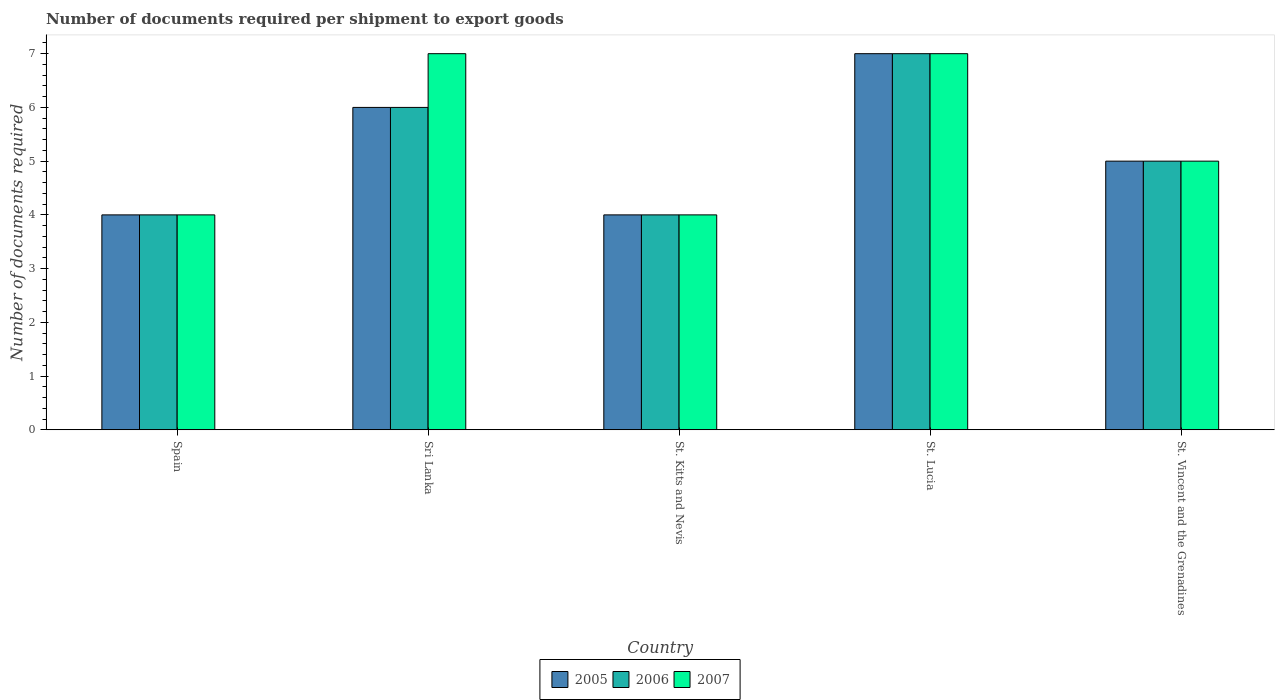How many different coloured bars are there?
Give a very brief answer. 3. How many groups of bars are there?
Your answer should be compact. 5. Are the number of bars on each tick of the X-axis equal?
Make the answer very short. Yes. How many bars are there on the 3rd tick from the right?
Provide a short and direct response. 3. Across all countries, what is the minimum number of documents required per shipment to export goods in 2005?
Ensure brevity in your answer.  4. In which country was the number of documents required per shipment to export goods in 2007 maximum?
Offer a very short reply. Sri Lanka. In which country was the number of documents required per shipment to export goods in 2006 minimum?
Your answer should be compact. Spain. In how many countries, is the number of documents required per shipment to export goods in 2006 greater than 5?
Offer a terse response. 2. What is the difference between the highest and the second highest number of documents required per shipment to export goods in 2007?
Provide a succinct answer. -2. What is the difference between the highest and the lowest number of documents required per shipment to export goods in 2005?
Provide a succinct answer. 3. In how many countries, is the number of documents required per shipment to export goods in 2006 greater than the average number of documents required per shipment to export goods in 2006 taken over all countries?
Provide a short and direct response. 2. Is the sum of the number of documents required per shipment to export goods in 2007 in Spain and St. Kitts and Nevis greater than the maximum number of documents required per shipment to export goods in 2005 across all countries?
Your answer should be very brief. Yes. What does the 3rd bar from the left in St. Lucia represents?
Keep it short and to the point. 2007. How many countries are there in the graph?
Ensure brevity in your answer.  5. Does the graph contain any zero values?
Your answer should be very brief. No. Where does the legend appear in the graph?
Make the answer very short. Bottom center. How many legend labels are there?
Your answer should be very brief. 3. What is the title of the graph?
Your answer should be compact. Number of documents required per shipment to export goods. What is the label or title of the Y-axis?
Your response must be concise. Number of documents required. What is the Number of documents required in 2005 in Spain?
Your answer should be very brief. 4. What is the Number of documents required of 2007 in Spain?
Your response must be concise. 4. What is the Number of documents required of 2005 in Sri Lanka?
Give a very brief answer. 6. What is the Number of documents required of 2006 in Sri Lanka?
Ensure brevity in your answer.  6. What is the Number of documents required of 2005 in St. Kitts and Nevis?
Give a very brief answer. 4. What is the Number of documents required in 2006 in St. Kitts and Nevis?
Provide a short and direct response. 4. What is the Number of documents required in 2006 in St. Vincent and the Grenadines?
Provide a short and direct response. 5. What is the Number of documents required of 2007 in St. Vincent and the Grenadines?
Provide a short and direct response. 5. Across all countries, what is the maximum Number of documents required of 2005?
Ensure brevity in your answer.  7. Across all countries, what is the maximum Number of documents required of 2007?
Your answer should be compact. 7. Across all countries, what is the minimum Number of documents required in 2005?
Make the answer very short. 4. Across all countries, what is the minimum Number of documents required of 2007?
Your answer should be compact. 4. What is the total Number of documents required in 2005 in the graph?
Provide a short and direct response. 26. What is the total Number of documents required in 2007 in the graph?
Make the answer very short. 27. What is the difference between the Number of documents required of 2005 in Spain and that in Sri Lanka?
Make the answer very short. -2. What is the difference between the Number of documents required of 2007 in Spain and that in Sri Lanka?
Provide a short and direct response. -3. What is the difference between the Number of documents required of 2006 in Spain and that in St. Kitts and Nevis?
Give a very brief answer. 0. What is the difference between the Number of documents required of 2007 in Spain and that in St. Kitts and Nevis?
Make the answer very short. 0. What is the difference between the Number of documents required of 2007 in Spain and that in St. Lucia?
Your answer should be compact. -3. What is the difference between the Number of documents required of 2006 in Spain and that in St. Vincent and the Grenadines?
Offer a terse response. -1. What is the difference between the Number of documents required in 2006 in Sri Lanka and that in St. Lucia?
Keep it short and to the point. -1. What is the difference between the Number of documents required of 2007 in Sri Lanka and that in St. Lucia?
Offer a very short reply. 0. What is the difference between the Number of documents required in 2005 in Sri Lanka and that in St. Vincent and the Grenadines?
Your response must be concise. 1. What is the difference between the Number of documents required in 2006 in Sri Lanka and that in St. Vincent and the Grenadines?
Provide a succinct answer. 1. What is the difference between the Number of documents required in 2007 in Sri Lanka and that in St. Vincent and the Grenadines?
Offer a terse response. 2. What is the difference between the Number of documents required of 2005 in St. Kitts and Nevis and that in St. Lucia?
Your answer should be compact. -3. What is the difference between the Number of documents required in 2006 in St. Kitts and Nevis and that in St. Vincent and the Grenadines?
Keep it short and to the point. -1. What is the difference between the Number of documents required of 2007 in St. Kitts and Nevis and that in St. Vincent and the Grenadines?
Your answer should be compact. -1. What is the difference between the Number of documents required in 2005 in St. Lucia and that in St. Vincent and the Grenadines?
Provide a short and direct response. 2. What is the difference between the Number of documents required in 2007 in St. Lucia and that in St. Vincent and the Grenadines?
Keep it short and to the point. 2. What is the difference between the Number of documents required in 2005 in Spain and the Number of documents required in 2007 in Sri Lanka?
Ensure brevity in your answer.  -3. What is the difference between the Number of documents required in 2006 in Spain and the Number of documents required in 2007 in Sri Lanka?
Ensure brevity in your answer.  -3. What is the difference between the Number of documents required of 2005 in Spain and the Number of documents required of 2006 in St. Kitts and Nevis?
Offer a terse response. 0. What is the difference between the Number of documents required in 2006 in Spain and the Number of documents required in 2007 in St. Kitts and Nevis?
Keep it short and to the point. 0. What is the difference between the Number of documents required in 2006 in Spain and the Number of documents required in 2007 in St. Lucia?
Make the answer very short. -3. What is the difference between the Number of documents required in 2005 in Spain and the Number of documents required in 2006 in St. Vincent and the Grenadines?
Make the answer very short. -1. What is the difference between the Number of documents required of 2005 in Spain and the Number of documents required of 2007 in St. Vincent and the Grenadines?
Keep it short and to the point. -1. What is the difference between the Number of documents required of 2006 in Spain and the Number of documents required of 2007 in St. Vincent and the Grenadines?
Offer a very short reply. -1. What is the difference between the Number of documents required of 2006 in Sri Lanka and the Number of documents required of 2007 in St. Lucia?
Make the answer very short. -1. What is the difference between the Number of documents required in 2005 in Sri Lanka and the Number of documents required in 2006 in St. Vincent and the Grenadines?
Offer a terse response. 1. What is the difference between the Number of documents required of 2006 in Sri Lanka and the Number of documents required of 2007 in St. Vincent and the Grenadines?
Give a very brief answer. 1. What is the difference between the Number of documents required of 2005 in St. Kitts and Nevis and the Number of documents required of 2006 in St. Lucia?
Provide a succinct answer. -3. What is the difference between the Number of documents required of 2005 in St. Kitts and Nevis and the Number of documents required of 2007 in St. Lucia?
Provide a succinct answer. -3. What is the difference between the Number of documents required of 2006 in St. Kitts and Nevis and the Number of documents required of 2007 in St. Lucia?
Ensure brevity in your answer.  -3. What is the difference between the Number of documents required of 2005 in St. Kitts and Nevis and the Number of documents required of 2006 in St. Vincent and the Grenadines?
Your answer should be very brief. -1. What is the difference between the Number of documents required in 2006 in St. Kitts and Nevis and the Number of documents required in 2007 in St. Vincent and the Grenadines?
Offer a terse response. -1. What is the difference between the Number of documents required in 2005 in St. Lucia and the Number of documents required in 2006 in St. Vincent and the Grenadines?
Your answer should be compact. 2. What is the difference between the Number of documents required in 2006 in St. Lucia and the Number of documents required in 2007 in St. Vincent and the Grenadines?
Ensure brevity in your answer.  2. What is the difference between the Number of documents required of 2005 and Number of documents required of 2006 in Spain?
Ensure brevity in your answer.  0. What is the difference between the Number of documents required in 2005 and Number of documents required in 2006 in Sri Lanka?
Ensure brevity in your answer.  0. What is the difference between the Number of documents required of 2005 and Number of documents required of 2007 in Sri Lanka?
Offer a very short reply. -1. What is the difference between the Number of documents required in 2006 and Number of documents required in 2007 in Sri Lanka?
Your response must be concise. -1. What is the difference between the Number of documents required of 2005 and Number of documents required of 2007 in St. Kitts and Nevis?
Your answer should be very brief. 0. What is the difference between the Number of documents required in 2006 and Number of documents required in 2007 in St. Kitts and Nevis?
Your answer should be very brief. 0. What is the difference between the Number of documents required of 2005 and Number of documents required of 2006 in St. Lucia?
Your response must be concise. 0. What is the difference between the Number of documents required in 2005 and Number of documents required in 2007 in St. Vincent and the Grenadines?
Ensure brevity in your answer.  0. What is the ratio of the Number of documents required in 2006 in Spain to that in St. Kitts and Nevis?
Ensure brevity in your answer.  1. What is the ratio of the Number of documents required in 2005 in Spain to that in St. Vincent and the Grenadines?
Make the answer very short. 0.8. What is the ratio of the Number of documents required in 2006 in Spain to that in St. Vincent and the Grenadines?
Your answer should be very brief. 0.8. What is the ratio of the Number of documents required of 2005 in Sri Lanka to that in St. Kitts and Nevis?
Your response must be concise. 1.5. What is the ratio of the Number of documents required of 2006 in Sri Lanka to that in St. Kitts and Nevis?
Provide a succinct answer. 1.5. What is the ratio of the Number of documents required in 2007 in Sri Lanka to that in St. Kitts and Nevis?
Make the answer very short. 1.75. What is the ratio of the Number of documents required in 2006 in Sri Lanka to that in St. Vincent and the Grenadines?
Ensure brevity in your answer.  1.2. What is the ratio of the Number of documents required of 2005 in St. Kitts and Nevis to that in St. Lucia?
Ensure brevity in your answer.  0.57. What is the ratio of the Number of documents required in 2005 in St. Kitts and Nevis to that in St. Vincent and the Grenadines?
Ensure brevity in your answer.  0.8. What is the ratio of the Number of documents required in 2006 in St. Kitts and Nevis to that in St. Vincent and the Grenadines?
Your response must be concise. 0.8. What is the ratio of the Number of documents required of 2007 in St. Kitts and Nevis to that in St. Vincent and the Grenadines?
Your response must be concise. 0.8. What is the ratio of the Number of documents required in 2006 in St. Lucia to that in St. Vincent and the Grenadines?
Your answer should be very brief. 1.4. What is the difference between the highest and the lowest Number of documents required in 2006?
Offer a terse response. 3. What is the difference between the highest and the lowest Number of documents required of 2007?
Your response must be concise. 3. 